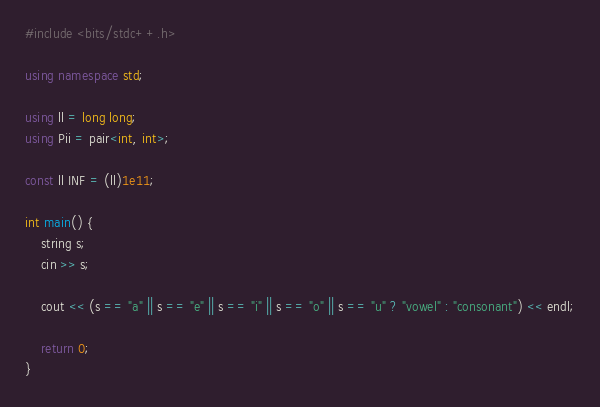<code> <loc_0><loc_0><loc_500><loc_500><_C++_>#include <bits/stdc++.h>

using namespace std;

using ll = long long;
using Pii = pair<int, int>;

const ll INF = (ll)1e11;

int main() {
    string s;
    cin >> s;

    cout << (s == "a" || s == "e" || s == "i" || s == "o" || s == "u" ? "vowel" : "consonant") << endl;

    return 0;
}
</code> 